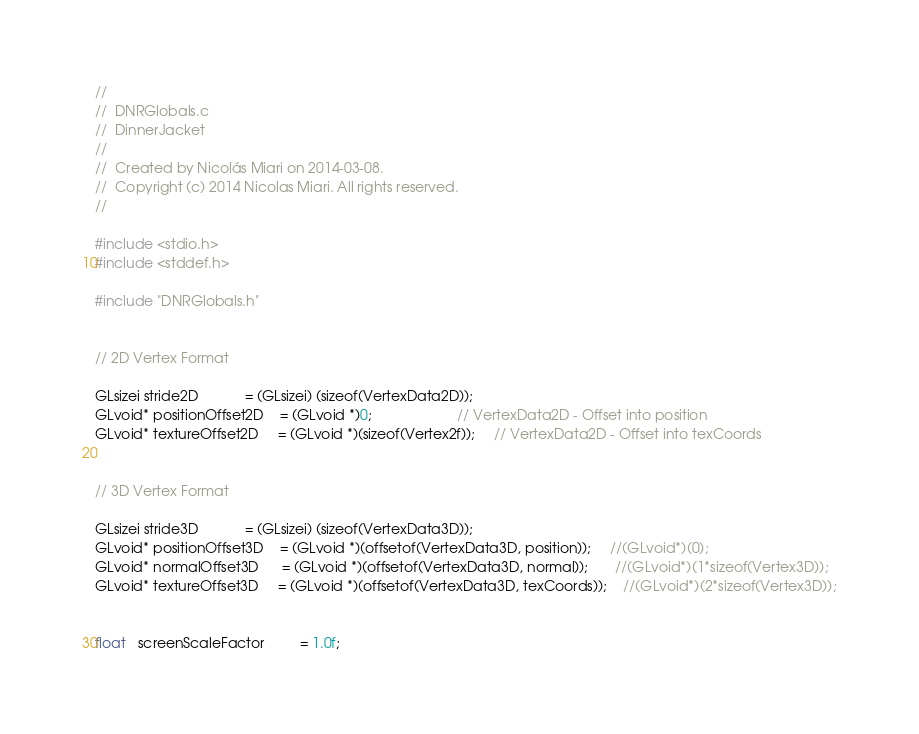Convert code to text. <code><loc_0><loc_0><loc_500><loc_500><_C_>//
//  DNRGlobals.c
//  DinnerJacket
//
//  Created by Nicolás Miari on 2014-03-08.
//  Copyright (c) 2014 Nicolas Miari. All rights reserved.
//

#include <stdio.h>
#include <stddef.h>

#include "DNRGlobals.h"


// 2D Vertex Format

GLsizei stride2D            = (GLsizei) (sizeof(VertexData2D));
GLvoid* positionOffset2D    = (GLvoid *)0;                      // VertexData2D - Offset into position
GLvoid* textureOffset2D     = (GLvoid *)(sizeof(Vertex2f));     // VertexData2D - Offset into texCoords


// 3D Vertex Format

GLsizei stride3D            = (GLsizei) (sizeof(VertexData3D));
GLvoid* positionOffset3D    = (GLvoid *)(offsetof(VertexData3D, position));     //(GLvoid*)(0);
GLvoid* normalOffset3D      = (GLvoid *)(offsetof(VertexData3D, normal));       //(GLvoid*)(1*sizeof(Vertex3D));
GLvoid* textureOffset3D     = (GLvoid *)(offsetof(VertexData3D, texCoords));    //(GLvoid*)(2*sizeof(Vertex3D));


float   screenScaleFactor         = 1.0f;

</code> 